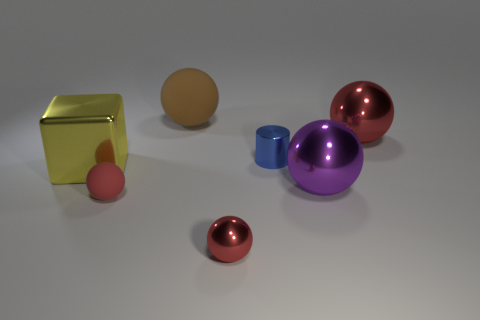How many red spheres must be subtracted to get 1 red spheres? 2 Subtract all cyan cubes. How many red spheres are left? 3 Subtract all large purple spheres. How many spheres are left? 4 Subtract 1 spheres. How many spheres are left? 4 Subtract all purple spheres. How many spheres are left? 4 Subtract all yellow balls. Subtract all red cubes. How many balls are left? 5 Add 2 large rubber spheres. How many objects exist? 9 Subtract all cylinders. How many objects are left? 6 Add 4 blue cylinders. How many blue cylinders exist? 5 Subtract 0 yellow spheres. How many objects are left? 7 